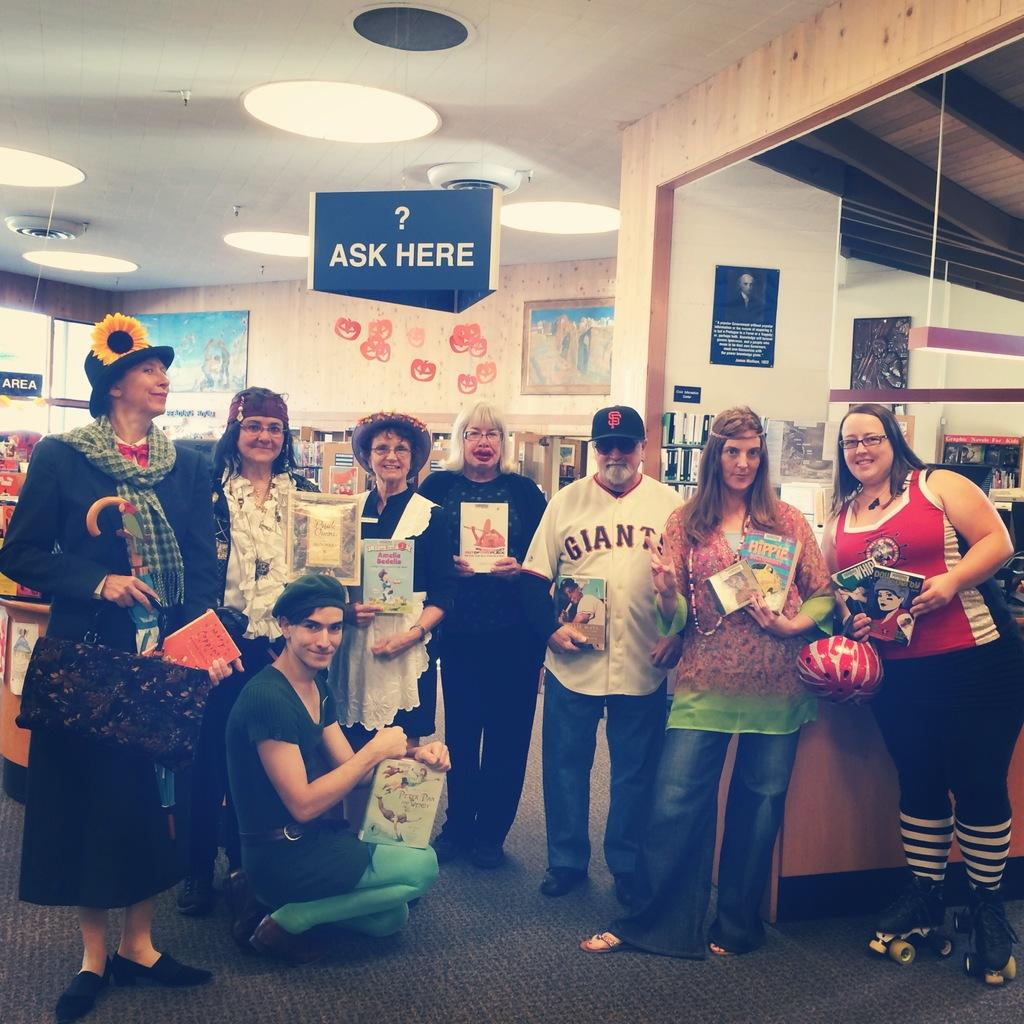<image>
Describe the image concisely. A group of people hold books in a library under an Ask Here sign. 